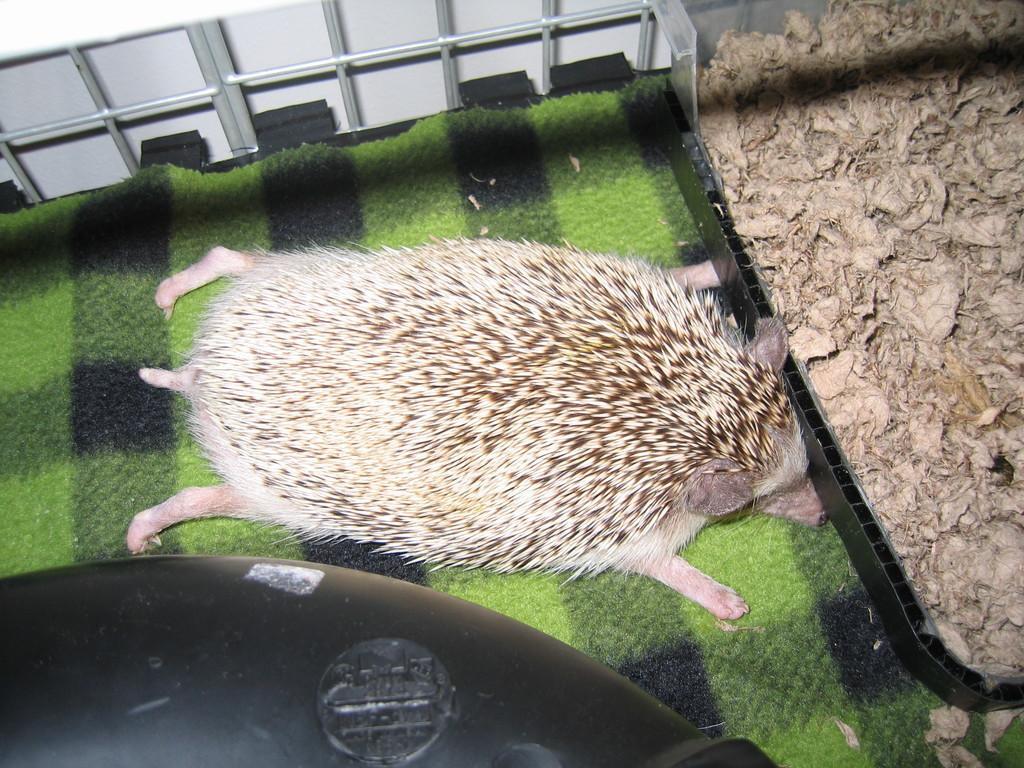How would you summarize this image in a sentence or two? In this image we can see an animal on a surface. On the right side, we can see dried leaves. At the top we can see a wall and metal cage. At the bottom we can see a black object. 